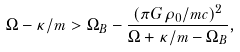<formula> <loc_0><loc_0><loc_500><loc_500>\Omega - \kappa / m > \Omega _ { B } - \frac { ( \pi G \rho _ { 0 } / m c ) ^ { 2 } } { \Omega + \kappa / m - \Omega _ { B } } ,</formula> 